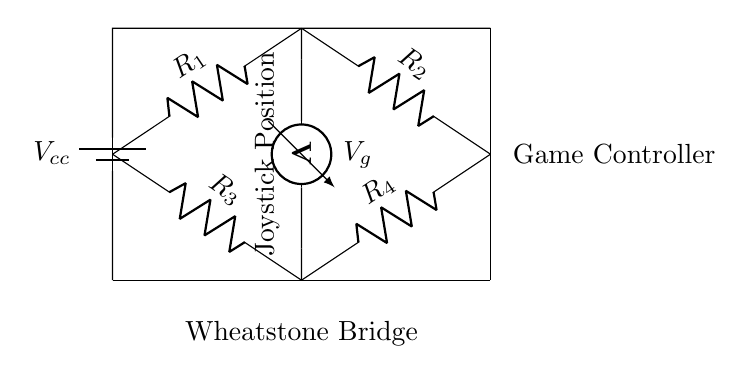What component acts as the variable resistance in the circuit? The variable resistance is often represented as one of the resistors in the Wheatstone bridge, typically associated with the joystick position, affecting the balance of the bridge.
Answer: Joystick Position What type of circuit is this? This circuit is a Wheatstone bridge, which is used to measure unknown resistances by balancing two legs of a bridge circuit.
Answer: Wheatstone Bridge What is the purpose of the voltmeter in the circuit? The voltmeter measures the potential difference across the bridge, which indicates the balance point and helps in determining the joystick position.
Answer: Measure Voltage How many resistors are present in the circuit? The diagram shows four resistors, which are part of the Wheatstone bridge configuration.
Answer: Four What is the source voltage labeled in the circuit? The source voltage provided to the circuit is labeled as Vcc, representing the total supply voltage for the Wheatstone bridge.
Answer: Vcc What does the term 'R1' signify in the circuit? R1 represents one of the fixed resistors in the Wheatstone bridge that contributes to the bridge's balance and sensitivity.
Answer: Fixed Resistor What could happen if one of the resistors is altered? Altering one of the resistors would change the balance of the Wheatstone bridge, potentially impacting the measurement of the joystick position and its accuracy.
Answer: Unbalanced Measurement 